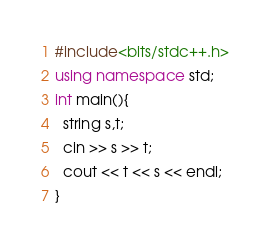<code> <loc_0><loc_0><loc_500><loc_500><_C++_>#include<bits/stdc++.h>
using namespace std;
int main(){
  string s,t;
  cin >> s >> t;
  cout << t << s << endl;
}</code> 